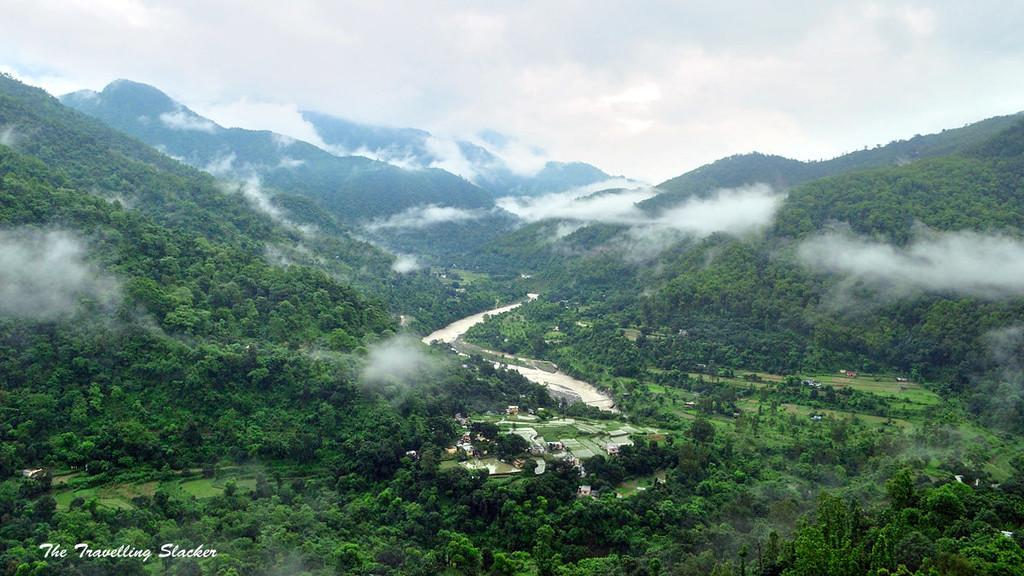What type of vegetation can be seen in the image? There are trees and grass visible in the image. What natural element is present in the image? There is water visible in the image. What type of structures are in the image? There are houses in the image. What is the weather like in the image? The sky is cloudy in the image. What geographical feature is present in the image? There are mountains in the image. What type of art is the queen admiring during recess in the image? There is no queen or recess present in the image, and therefore no such activity can be observed. 